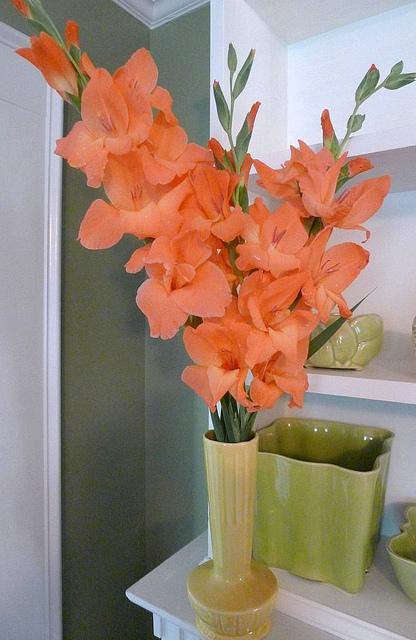What type of flower arrangement is this?
Answer briefly. Vase. Are the flowers orange?
Be succinct. Yes. How many flowers in the vase?
Quick response, please. 3. Are the vases on the shelf all the same color?
Concise answer only. No. 